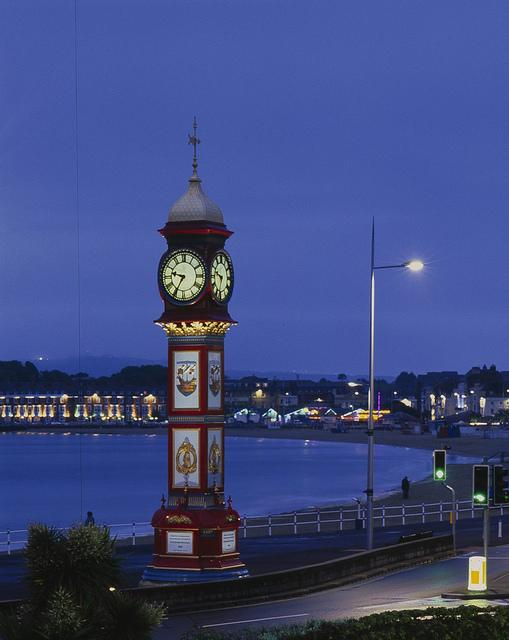What should traffic do by the light? go 